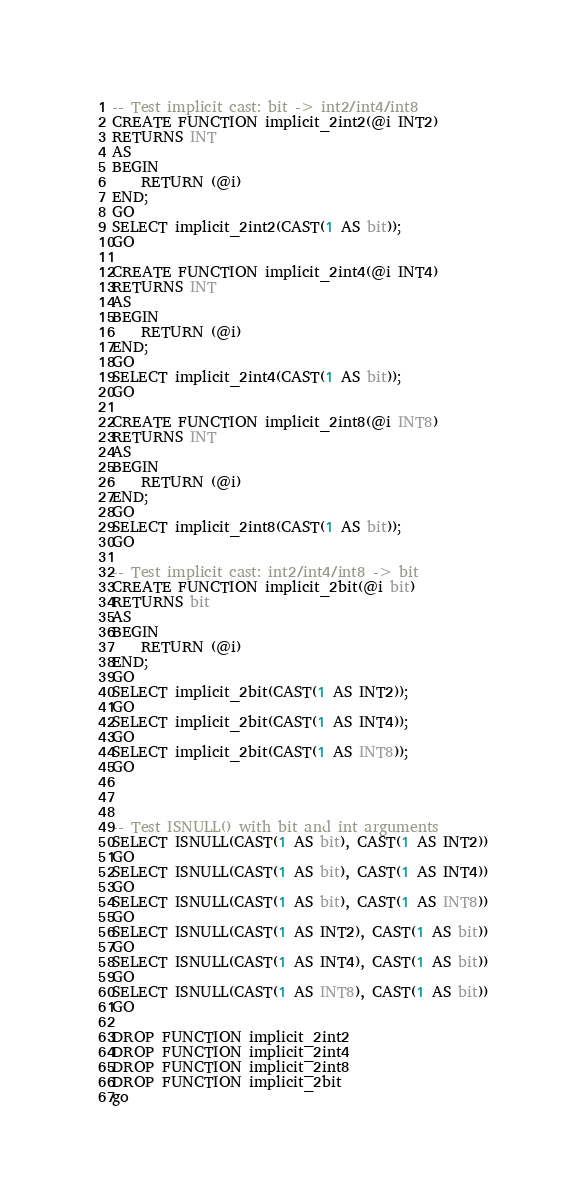Convert code to text. <code><loc_0><loc_0><loc_500><loc_500><_SQL_>-- Test implicit cast: bit -> int2/int4/int8
CREATE FUNCTION implicit_2int2(@i INT2)
RETURNS INT
AS
BEGIN
    RETURN (@i)
END;
GO
SELECT implicit_2int2(CAST(1 AS bit));
GO

CREATE FUNCTION implicit_2int4(@i INT4)
RETURNS INT
AS
BEGIN
    RETURN (@i)
END;
GO
SELECT implicit_2int4(CAST(1 AS bit));
GO

CREATE FUNCTION implicit_2int8(@i INT8)
RETURNS INT
AS
BEGIN
    RETURN (@i)
END;
GO
SELECT implicit_2int8(CAST(1 AS bit));
GO

-- Test implicit cast: int2/int4/int8 -> bit
CREATE FUNCTION implicit_2bit(@i bit)
RETURNS bit
AS
BEGIN
    RETURN (@i)
END;
GO
SELECT implicit_2bit(CAST(1 AS INT2));
GO
SELECT implicit_2bit(CAST(1 AS INT4));
GO
SELECT implicit_2bit(CAST(1 AS INT8));
GO



-- Test ISNULL() with bit and int arguments
SELECT ISNULL(CAST(1 AS bit), CAST(1 AS INT2))
GO
SELECT ISNULL(CAST(1 AS bit), CAST(1 AS INT4))
GO
SELECT ISNULL(CAST(1 AS bit), CAST(1 AS INT8))
GO
SELECT ISNULL(CAST(1 AS INT2), CAST(1 AS bit))
GO
SELECT ISNULL(CAST(1 AS INT4), CAST(1 AS bit))
GO
SELECT ISNULL(CAST(1 AS INT8), CAST(1 AS bit))
GO

DROP FUNCTION implicit_2int2
DROP FUNCTION implicit_2int4
DROP FUNCTION implicit_2int8
DROP FUNCTION implicit_2bit
go
</code> 